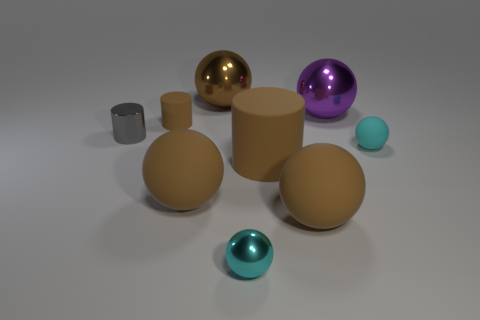There is a small matte object to the right of the purple sphere; is its shape the same as the cyan metal thing?
Offer a terse response. Yes. What number of spheres are in front of the brown shiny thing and behind the small gray metal object?
Your answer should be compact. 1. What is the big cylinder made of?
Give a very brief answer. Rubber. Is there anything else that has the same color as the tiny metal ball?
Your response must be concise. Yes. Does the purple object have the same material as the tiny brown cylinder?
Keep it short and to the point. No. What number of tiny metal balls are behind the rubber thing behind the tiny rubber object to the right of the cyan shiny ball?
Provide a succinct answer. 0. How many cyan matte balls are there?
Ensure brevity in your answer.  1. Are there fewer tiny things that are on the left side of the cyan rubber object than small things that are in front of the big matte cylinder?
Keep it short and to the point. No. Is the number of cyan rubber balls that are in front of the big matte cylinder less than the number of balls?
Offer a very short reply. Yes. There is a tiny object behind the small metal object on the left side of the large brown rubber thing that is on the left side of the tiny cyan metal object; what is its material?
Ensure brevity in your answer.  Rubber. 